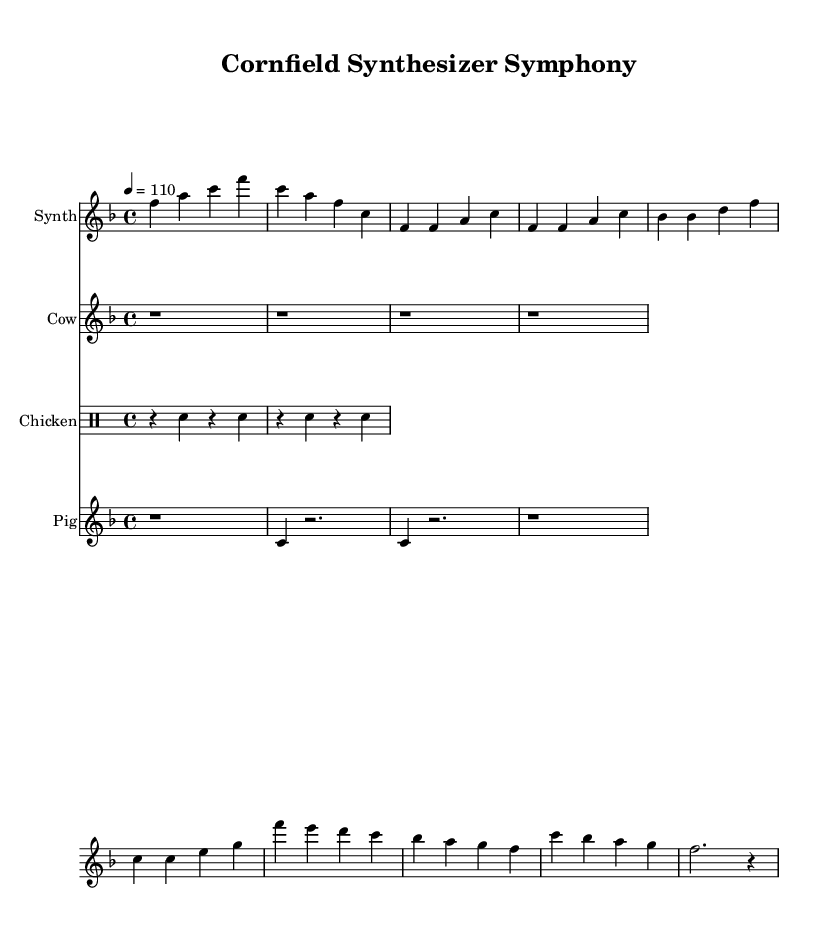What is the key signature of this music? The key signature is F major, which contains one flat (B flat).
Answer: F major What is the time signature of this music? The time signature is 4/4, indicating four beats per measure and a quarter note receives one beat.
Answer: 4/4 What is the tempo marking for this piece? The tempo marking is "quarter note = 110," indicating the speed at which the piece should be played.
Answer: 110 How many measures are in the synthesizer part? Counting the measures in the synthesizer part, there are ten measures shown in the score.
Answer: Ten What instrument plays the synthesized cow sounds? The synthesized cow sounds are represented in the score by the instrument named "Cow."
Answer: Cow Which animal sound is represented by the drum mode? The chicken sounds represented in the score are produced in drum mode with snare hits.
Answer: Chicken What is the relationship between the thematic elements and the animal sounds used in this piece? The animal sounds, like cow moos and chicken clucks, are integrated into the electronic reinterpretation, creating a fusion of folk music with synthesized farm life imagery.
Answer: Fusion of folk and farm life 